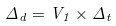Convert formula to latex. <formula><loc_0><loc_0><loc_500><loc_500>\Delta _ { d } = V _ { 1 } \times \Delta _ { t }</formula> 